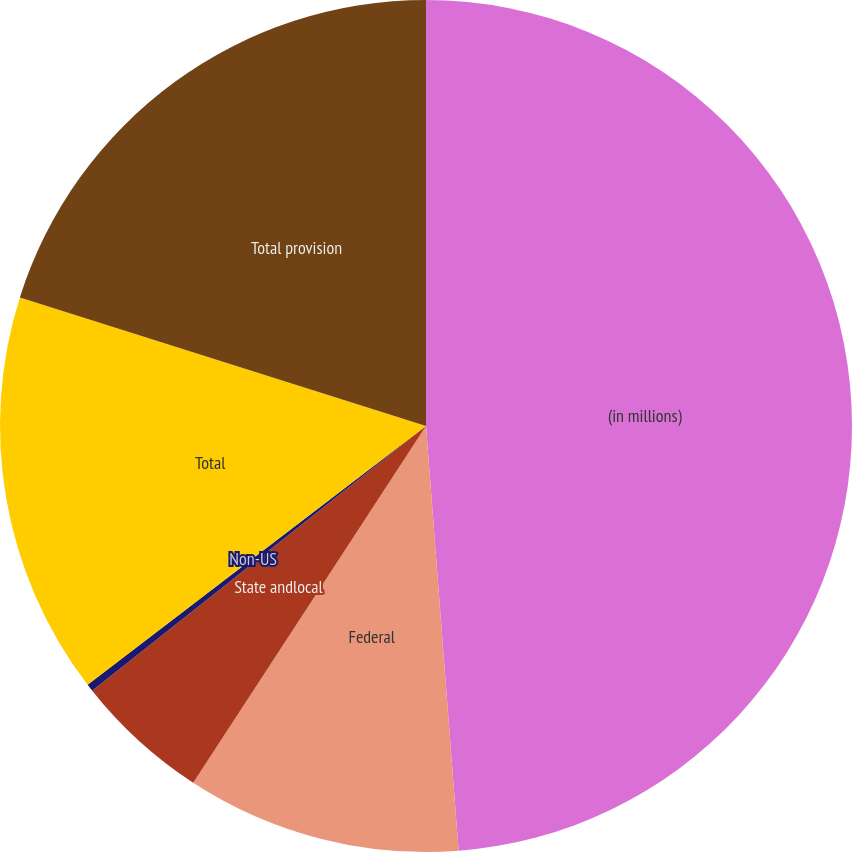<chart> <loc_0><loc_0><loc_500><loc_500><pie_chart><fcel>(in millions)<fcel>Federal<fcel>State andlocal<fcel>Non-US<fcel>Total<fcel>Total provision<nl><fcel>48.78%<fcel>10.42%<fcel>5.13%<fcel>0.28%<fcel>15.27%<fcel>20.12%<nl></chart> 